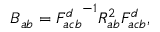Convert formula to latex. <formula><loc_0><loc_0><loc_500><loc_500>B _ { a b } = { F _ { a c b } ^ { d } } ^ { - 1 } R _ { a b } ^ { 2 } F _ { a c b } ^ { d } ,</formula> 